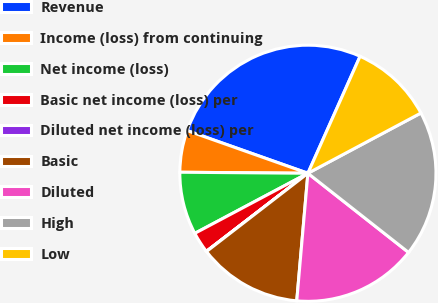<chart> <loc_0><loc_0><loc_500><loc_500><pie_chart><fcel>Revenue<fcel>Income (loss) from continuing<fcel>Net income (loss)<fcel>Basic net income (loss) per<fcel>Diluted net income (loss) per<fcel>Basic<fcel>Diluted<fcel>High<fcel>Low<nl><fcel>26.27%<fcel>5.28%<fcel>7.9%<fcel>2.66%<fcel>0.03%<fcel>13.15%<fcel>15.78%<fcel>18.4%<fcel>10.53%<nl></chart> 